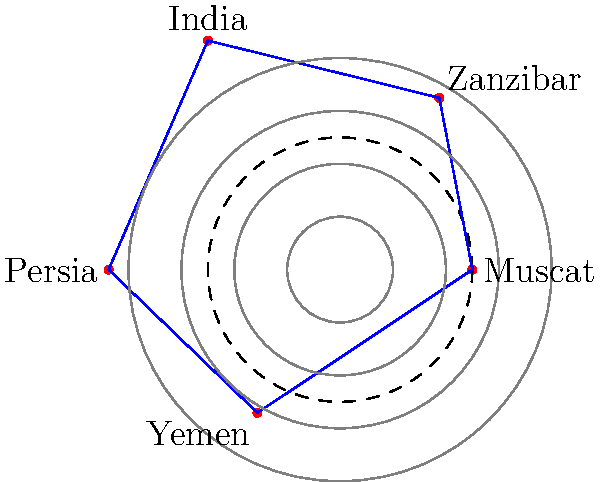Based on the polar map projection of Omani trade routes, which destination appears to be the farthest from Muscat in terms of trade distance? To determine the farthest destination from Muscat in terms of trade distance, we need to analyze the polar map projection:

1. Muscat is at the center of the polar projection, represented by the innermost point.
2. The distance from Muscat to each destination is represented by the length of the line connecting Muscat to that point.
3. The destinations shown are Zanzibar, India, Persia, and Yemen.
4. Comparing the lengths of the lines:
   - Zanzibar: moderate length
   - India: longest line
   - Persia: slightly shorter than India
   - Yemen: shortest line

5. The line representing the trade route to India extends the farthest from the center (Muscat).

Therefore, based on this polar map projection, India appears to be the farthest destination from Muscat in terms of trade distance.
Answer: India 